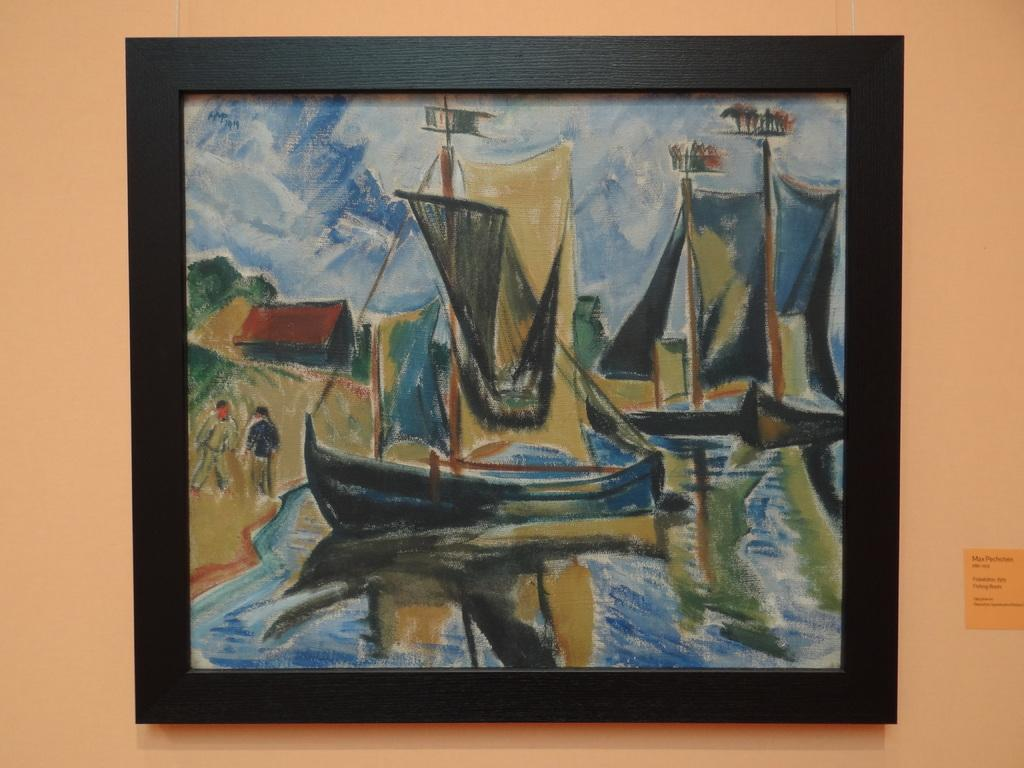What is hanging on the wall in the image? There is a picture frame on the wall. What is depicted within the picture frame? The picture frame contains images of boats. How many passengers are visible on the boats in the image? There are no passengers visible in the image, as the picture frame contains images of boats, not actual boats with people on them. 